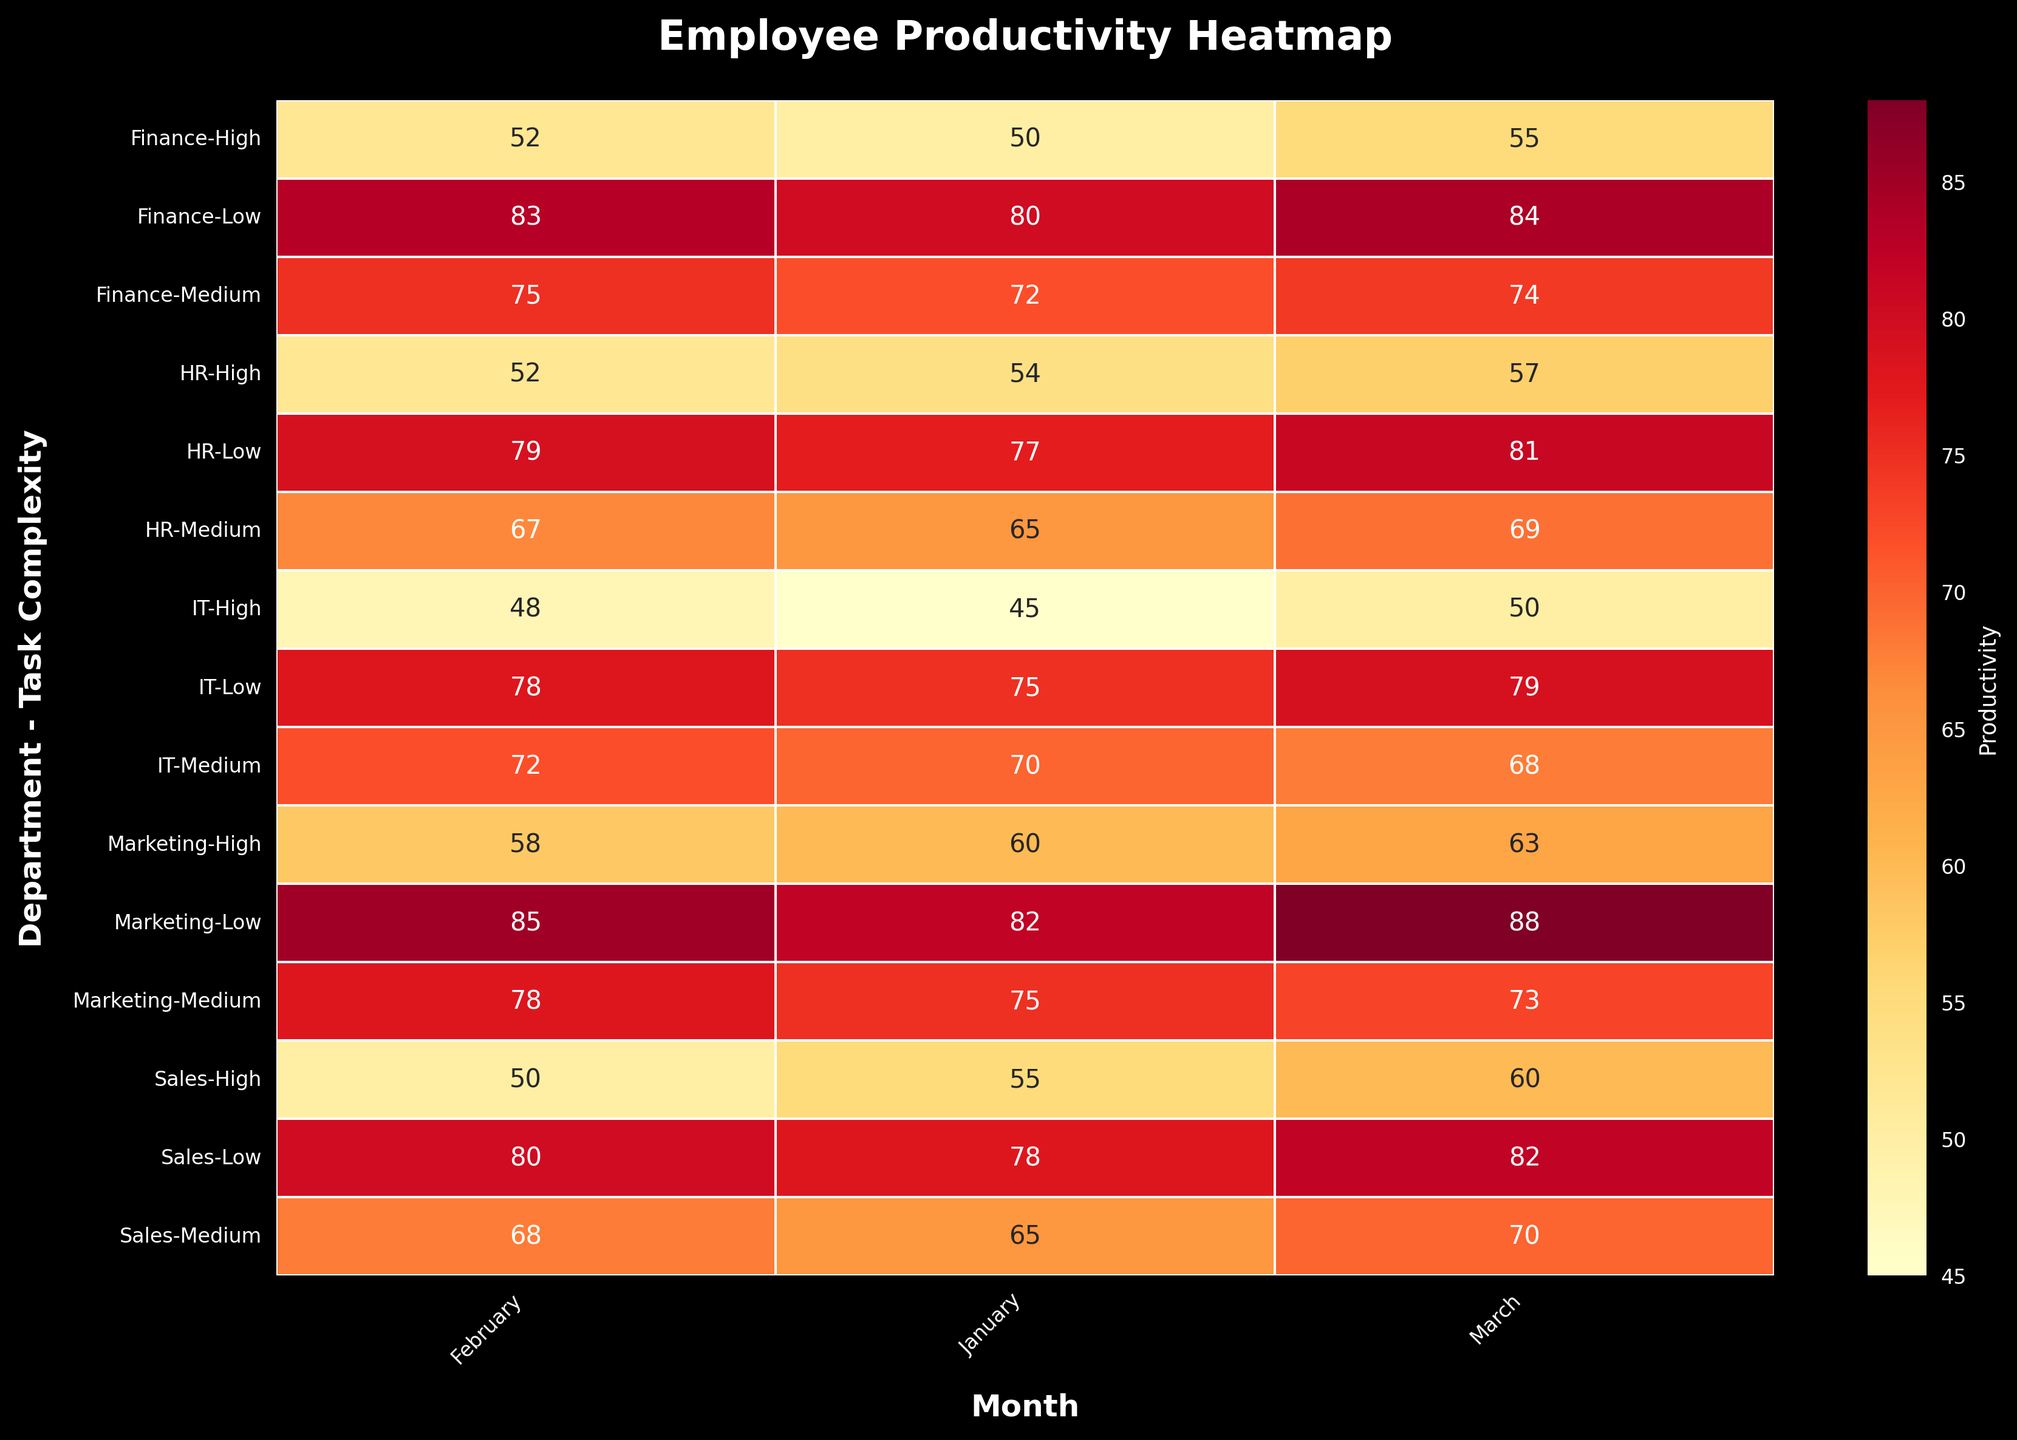What is the title of the heatmap? The title is usually displayed at the top of the heatmap. We can simply read the title from there.
Answer: Employee Productivity Heatmap Which department had the highest productivity for low-complexity tasks in March? Locate March along the x-axis, then find the low-complexity row for each department and identify the highest value. The row for Marketing (Low) in March has the highest value of 88.
Answer: Marketing How does the productivity in the IT department for high-complexity tasks compare between January and February? Locate the IT department rows, then find the high-complexity tasks for January and February. Noting the values are 45 for January and 48 for February, compare these values.
Answer: It increased Which department saw the largest improvement in productivity for high-complexity tasks from January to March? Identify the high-complexity productivity values for each department in January and March, and calculate the difference. Marketing shows an increase from 60 to 63, which is the largest improvement of 3 units.
Answer: Marketing What's the average productivity for medium-complexity tasks across all departments in February? Locate February and find all medium-complexity tasks for all departments. The values are 68, 78, 72, 75, and 67. Calculate their average: (68 + 78 + 72 + 75 + 67) / 5 = 72.
Answer: 72 Which type of task complexity shows the least variation in productivity among all departments in January? Look at the productivity values for all departments for each task complexity in January. Calculate the range for low (82-75=7), medium (75-65=10), and high (60-45=15) complexities. The lowest variation is in low-complexity tasks.
Answer: Low What is the productivity difference for the Finance department between low and high-complexity tasks in March? Locate the Finance department rows for March, then subtract the high-complexity task value from the low-complexity task value: 84 - 55 = 29.
Answer: 29 Is any department consistently more productive (across all three task complexities) in February compared to January? Compare the productivity values for each department in January and February for all task complexities. Confirm that each task complexity value in February is greater compared to January for a department. Both Sales and IT meet this condition.
Answer: Sales, IT Which month shows the highest overall productivity for the HR department across all task complexities? Summarize the productivity values of all task complexities for HR in each month and identify the highest total. January sums to 196, February to 198, and March to 207. The highest total occurs in March.
Answer: March 